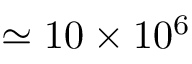<formula> <loc_0><loc_0><loc_500><loc_500>\simeq 1 0 \times 1 0 ^ { 6 }</formula> 